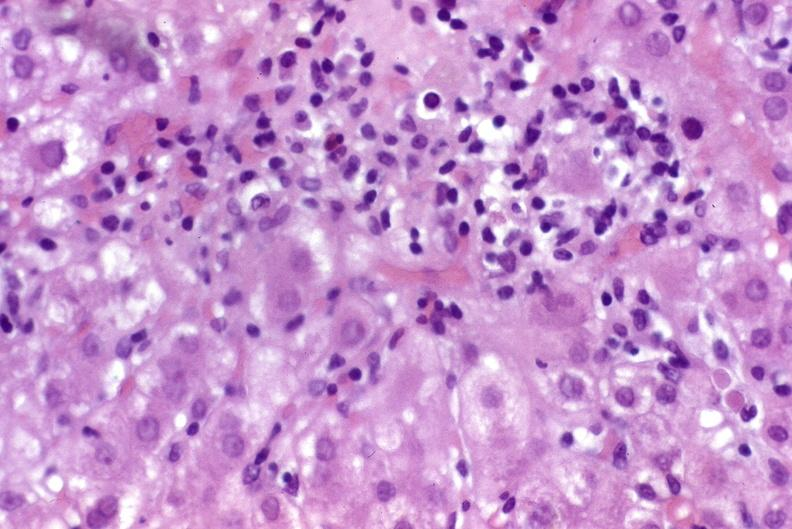s hepatobiliary present?
Answer the question using a single word or phrase. Yes 